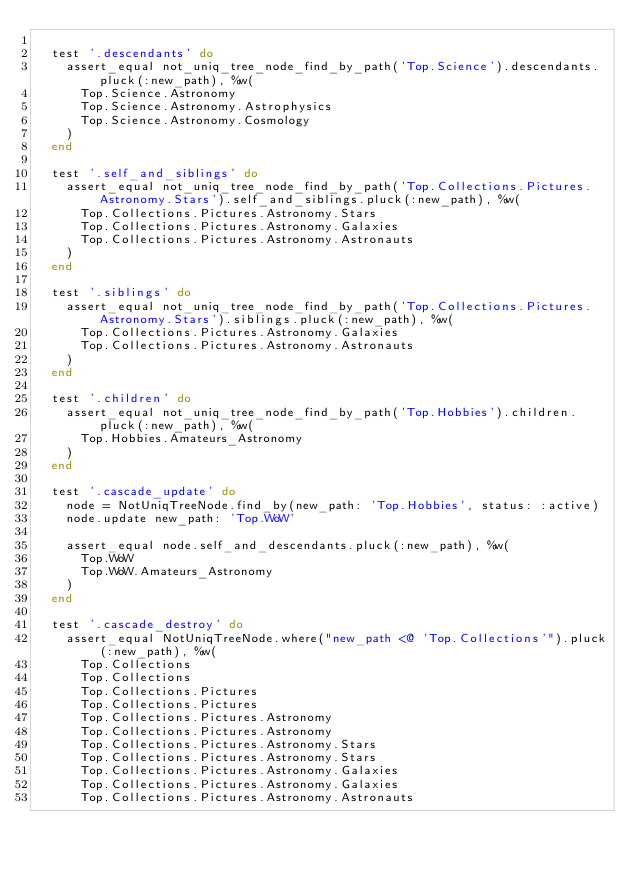<code> <loc_0><loc_0><loc_500><loc_500><_Ruby_>
  test '.descendants' do
    assert_equal not_uniq_tree_node_find_by_path('Top.Science').descendants.pluck(:new_path), %w(
      Top.Science.Astronomy
      Top.Science.Astronomy.Astrophysics
      Top.Science.Astronomy.Cosmology
    )
  end

  test '.self_and_siblings' do
    assert_equal not_uniq_tree_node_find_by_path('Top.Collections.Pictures.Astronomy.Stars').self_and_siblings.pluck(:new_path), %w(
      Top.Collections.Pictures.Astronomy.Stars
      Top.Collections.Pictures.Astronomy.Galaxies
      Top.Collections.Pictures.Astronomy.Astronauts
    )
  end

  test '.siblings' do
    assert_equal not_uniq_tree_node_find_by_path('Top.Collections.Pictures.Astronomy.Stars').siblings.pluck(:new_path), %w(
      Top.Collections.Pictures.Astronomy.Galaxies
      Top.Collections.Pictures.Astronomy.Astronauts
    )
  end

  test '.children' do
    assert_equal not_uniq_tree_node_find_by_path('Top.Hobbies').children.pluck(:new_path), %w(
      Top.Hobbies.Amateurs_Astronomy
    )
  end

  test '.cascade_update' do
    node = NotUniqTreeNode.find_by(new_path: 'Top.Hobbies', status: :active)
    node.update new_path: 'Top.WoW'

    assert_equal node.self_and_descendants.pluck(:new_path), %w(
      Top.WoW
      Top.WoW.Amateurs_Astronomy
    )
  end

  test '.cascade_destroy' do
    assert_equal NotUniqTreeNode.where("new_path <@ 'Top.Collections'").pluck(:new_path), %w(
      Top.Collections
      Top.Collections
      Top.Collections.Pictures
      Top.Collections.Pictures
      Top.Collections.Pictures.Astronomy
      Top.Collections.Pictures.Astronomy
      Top.Collections.Pictures.Astronomy.Stars
      Top.Collections.Pictures.Astronomy.Stars
      Top.Collections.Pictures.Astronomy.Galaxies
      Top.Collections.Pictures.Astronomy.Galaxies
      Top.Collections.Pictures.Astronomy.Astronauts</code> 